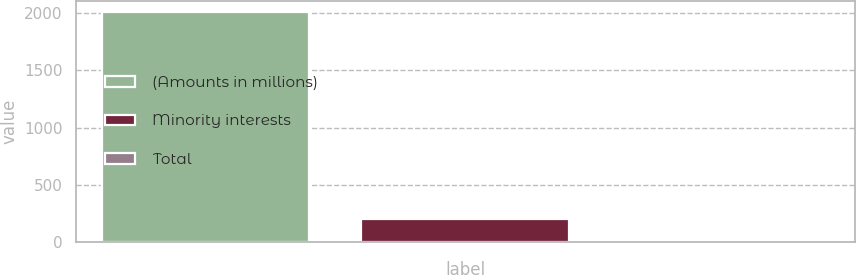<chart> <loc_0><loc_0><loc_500><loc_500><bar_chart><fcel>(Amounts in millions)<fcel>Minority interests<fcel>Total<nl><fcel>2007<fcel>202.95<fcel>2.5<nl></chart> 